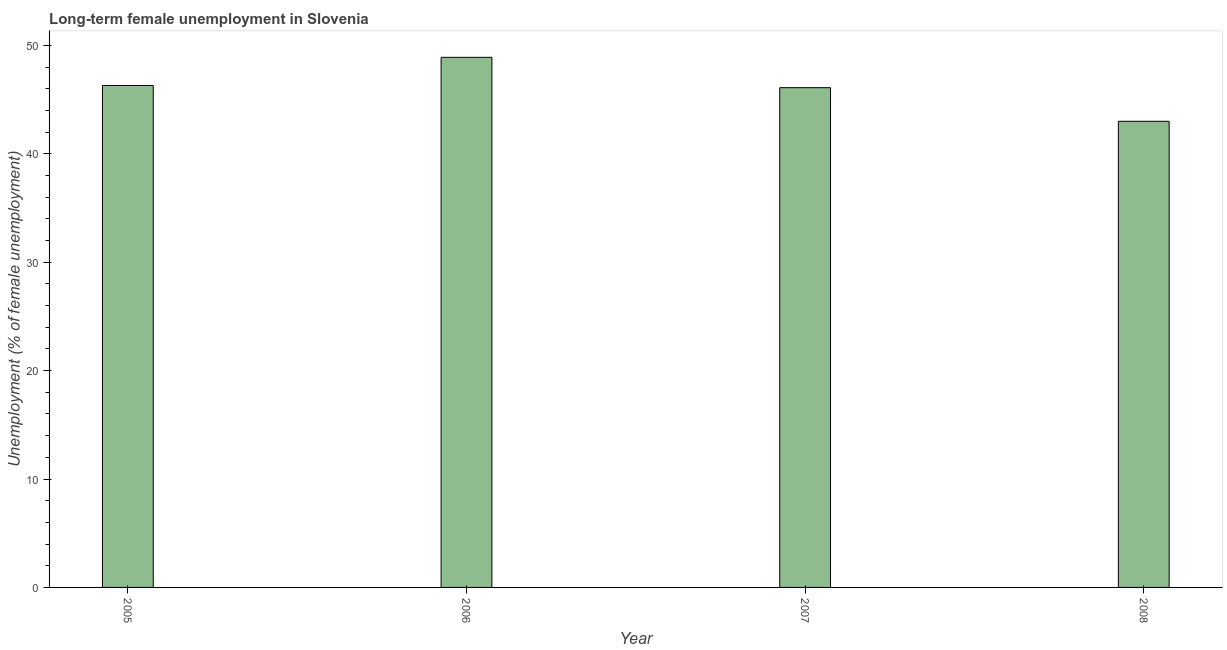Does the graph contain grids?
Provide a succinct answer. No. What is the title of the graph?
Provide a short and direct response. Long-term female unemployment in Slovenia. What is the label or title of the Y-axis?
Provide a succinct answer. Unemployment (% of female unemployment). What is the long-term female unemployment in 2008?
Offer a terse response. 43. Across all years, what is the maximum long-term female unemployment?
Keep it short and to the point. 48.9. What is the sum of the long-term female unemployment?
Ensure brevity in your answer.  184.3. What is the difference between the long-term female unemployment in 2006 and 2008?
Offer a terse response. 5.9. What is the average long-term female unemployment per year?
Offer a terse response. 46.08. What is the median long-term female unemployment?
Your answer should be very brief. 46.2. Do a majority of the years between 2007 and 2005 (inclusive) have long-term female unemployment greater than 24 %?
Provide a succinct answer. Yes. What is the ratio of the long-term female unemployment in 2006 to that in 2008?
Your answer should be compact. 1.14. Is the long-term female unemployment in 2007 less than that in 2008?
Give a very brief answer. No. Is the difference between the long-term female unemployment in 2005 and 2008 greater than the difference between any two years?
Your answer should be compact. No. What is the difference between the highest and the second highest long-term female unemployment?
Provide a short and direct response. 2.6. What is the difference between the highest and the lowest long-term female unemployment?
Your response must be concise. 5.9. In how many years, is the long-term female unemployment greater than the average long-term female unemployment taken over all years?
Give a very brief answer. 3. How many years are there in the graph?
Ensure brevity in your answer.  4. What is the difference between two consecutive major ticks on the Y-axis?
Your answer should be compact. 10. Are the values on the major ticks of Y-axis written in scientific E-notation?
Give a very brief answer. No. What is the Unemployment (% of female unemployment) of 2005?
Offer a terse response. 46.3. What is the Unemployment (% of female unemployment) of 2006?
Offer a terse response. 48.9. What is the Unemployment (% of female unemployment) of 2007?
Provide a succinct answer. 46.1. What is the Unemployment (% of female unemployment) in 2008?
Ensure brevity in your answer.  43. What is the difference between the Unemployment (% of female unemployment) in 2005 and 2007?
Give a very brief answer. 0.2. What is the ratio of the Unemployment (% of female unemployment) in 2005 to that in 2006?
Offer a terse response. 0.95. What is the ratio of the Unemployment (% of female unemployment) in 2005 to that in 2008?
Give a very brief answer. 1.08. What is the ratio of the Unemployment (% of female unemployment) in 2006 to that in 2007?
Your response must be concise. 1.06. What is the ratio of the Unemployment (% of female unemployment) in 2006 to that in 2008?
Make the answer very short. 1.14. What is the ratio of the Unemployment (% of female unemployment) in 2007 to that in 2008?
Offer a terse response. 1.07. 